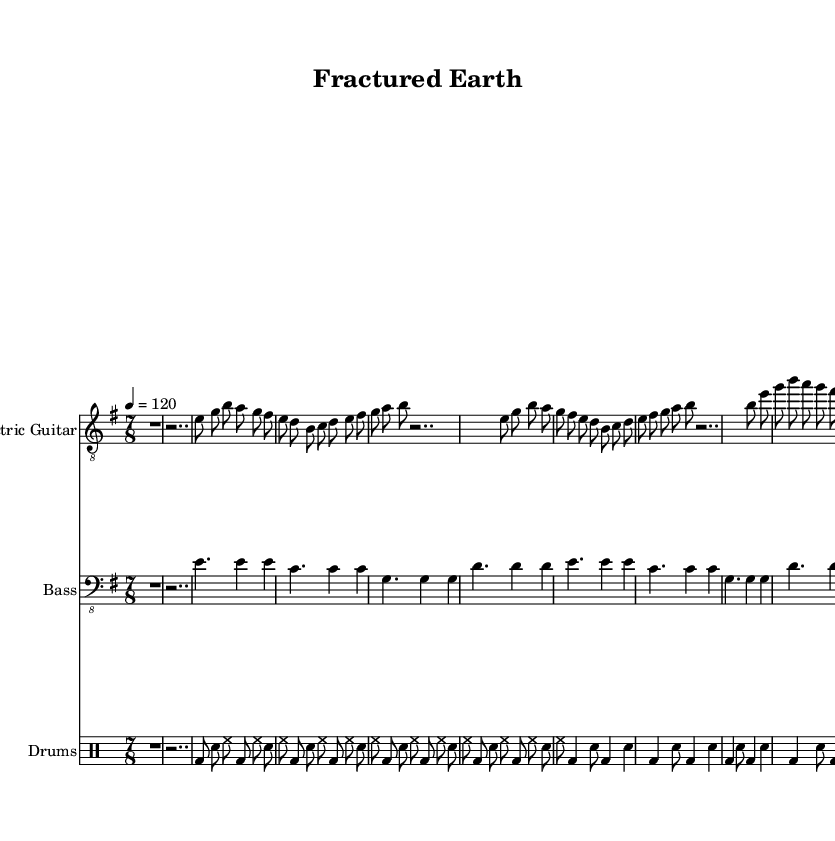What is the key signature of this composition? The key signature is E minor, which has one sharp (F#). This can be identified at the beginning of the staff where the sharp is indicated.
Answer: E minor What is the time signature of the piece? The time signature is 7/8, as indicated at the start of the music. This means there are seven beats in a measure, with the eighth note getting the beat.
Answer: 7/8 What is the tempo marking for the piece? The tempo marking is "4 = 120," which indicates that there are 120 beats per minute and a quarter note gets one beat. This is found in the tempo section at the beginning of the score.
Answer: 120 How many times is the verse repeated? The verse section is repeated four times, as stated by "repeat unfold 4" in both the electric guitar and bass guitar parts.
Answer: 4 What type of guitar clef is used in the part? The guitar part uses treble clef, indicated by "clef 'treble_8'" in the electric guitar staff. This clef is standard for guitar music.
Answer: Treble clef In the chorus section, how many measures are there? The chorus is repeated twice, and each repeat consists of four measures resulting in a total of eight measures. Counting the repeats confirms this as each part clearly shows "repeat unfold 2."
Answer: 8 measures 